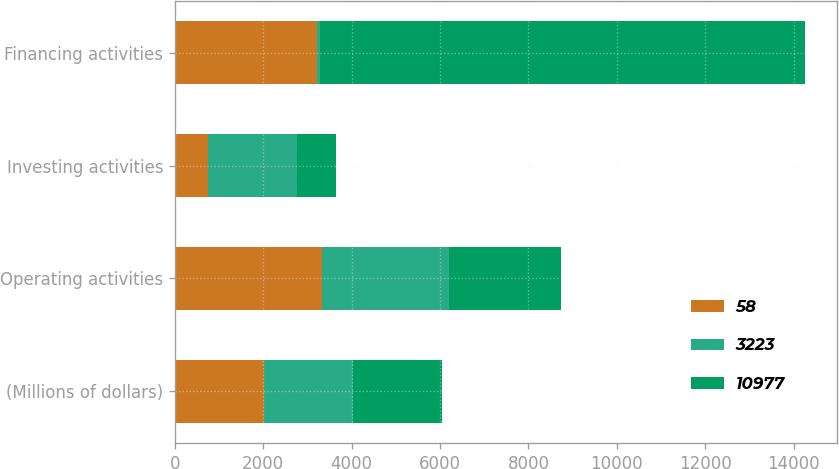Convert chart to OTSL. <chart><loc_0><loc_0><loc_500><loc_500><stacked_bar_chart><ecel><fcel>(Millions of dollars)<fcel>Operating activities<fcel>Investing activities<fcel>Financing activities<nl><fcel>58<fcel>2019<fcel>3330<fcel>741<fcel>3223<nl><fcel>3223<fcel>2018<fcel>2865<fcel>2019<fcel>58<nl><fcel>10977<fcel>2017<fcel>2550<fcel>883<fcel>10977<nl></chart> 